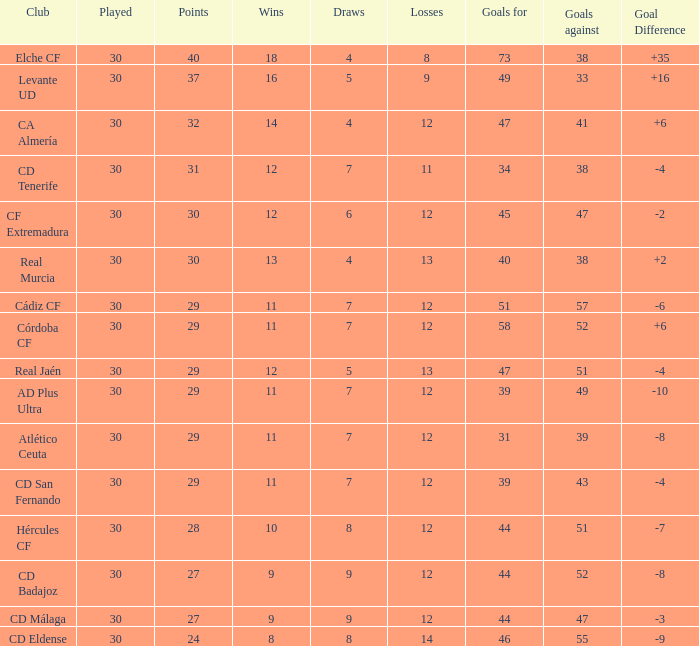What is the lowest amount of draws with less than 12 wins and less than 30 played? None. 